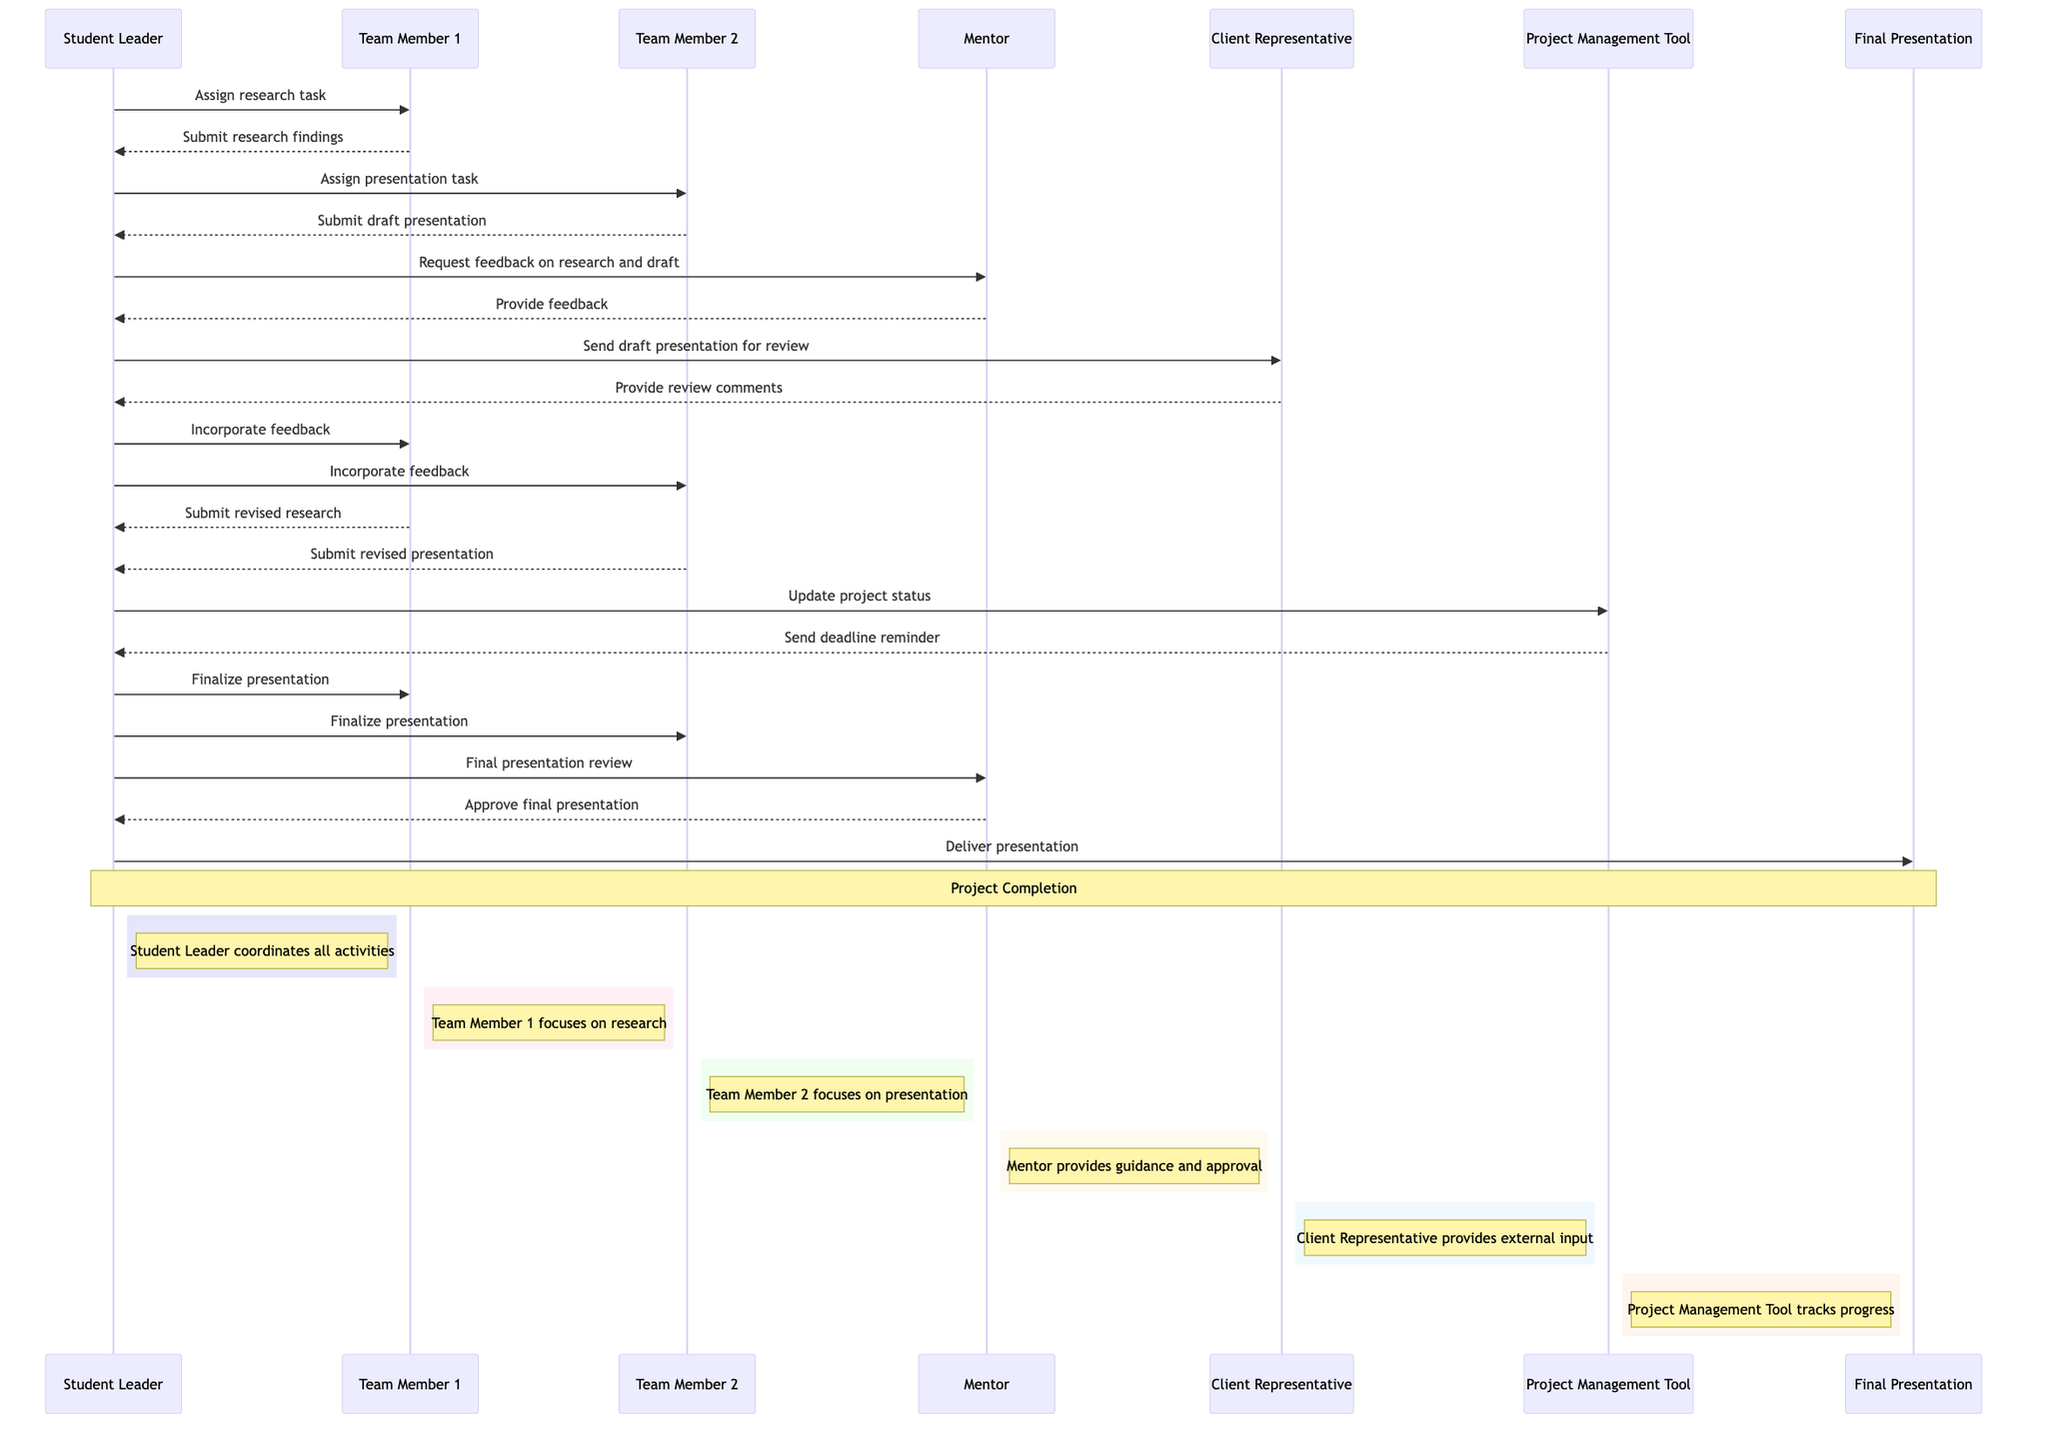What is the first action taken by the Student Leader? The first action in the sequence is when the Student Leader assigns a research task to Team Member 1. This is the initial message and sets off the project activities.
Answer: Assign research task How many team members are involved in the project? There are two team members involved in the project, Team Member 1 and Team Member 2. The diagram explicitly shows both contributing to different tasks.
Answer: Two Who provides the final feedback on the presentation? The final feedback on the presentation is provided by the Mentor. The Student Leader requests a final review from the Mentor and receives approval, indicating the Mentor's critical role in the verification process.
Answer: Mentor What task does Team Member 2 complete? Team Member 2 completes the task of submitting the draft presentation. This task follows the initial assignment from the Student Leader and is a crucial step in the project timeline.
Answer: Submit draft presentation After the draft presentation, what does the Client Representative do? After receiving the draft presentation, the Client Representative provides review comments back to the Student Leader. This interaction is important for obtaining client input and improving the project before finalization.
Answer: Provide review comments Which tool is used for tracking project progress? The Project Management Tool is used for tracking project progress. It sends reminders about deadlines and records the status of the project, helping manage tasks efficiently.
Answer: Project Management Tool How many feedback loops are present in the diagram? There are two feedback loops in the diagram. The first is where the Mentor provides feedback after reviewing the research and draft presentation, and the second feedback loop involves incorporating the client representative's comments into the final presentation.
Answer: Two What happens immediately before the final presentation is delivered? Before the final presentation is delivered, the Student Leader receives approval for the final presentation from the Mentor. This step completes the preparation necessary for the delivery.
Answer: Approve final presentation What is the purpose of the Task List as mentioned in the diagram? The Task List is implied to be used to manage tasks throughout the project, though it isn't directly interacted with in the sequence. It helps ensure that team members know their responsibilities.
Answer: Manage tasks 